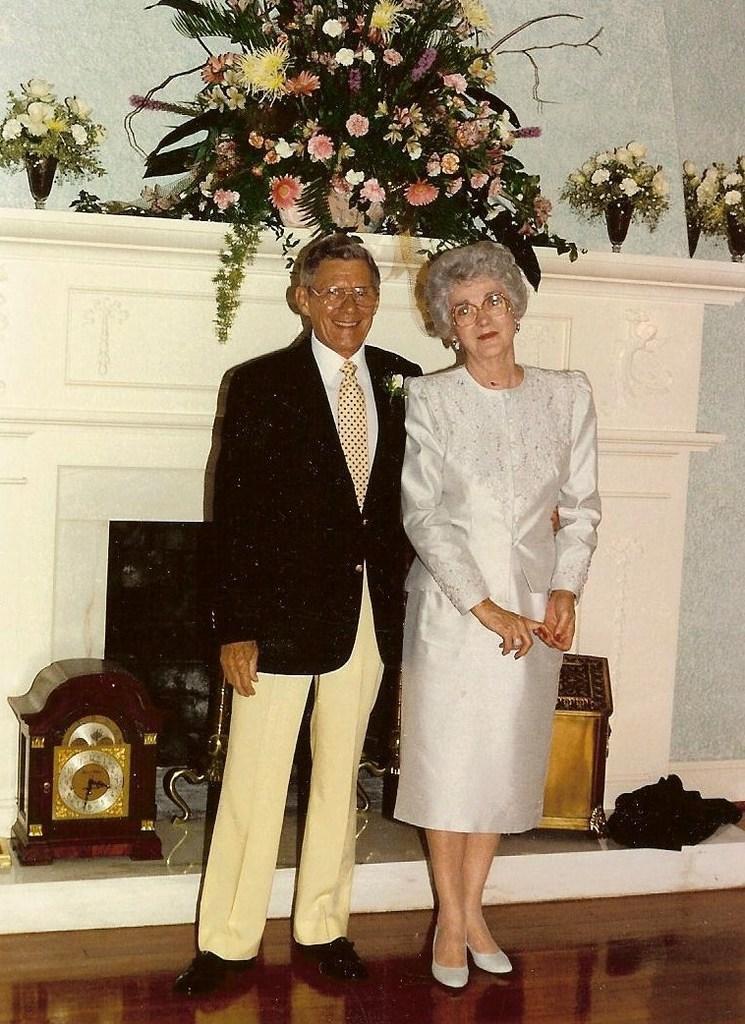In one or two sentences, can you explain what this image depicts? In this image we can see a man a man a woman standing on the floor and in the background there is a clock and few objects and on the wall there is a flower bouquet and few flower vases. 